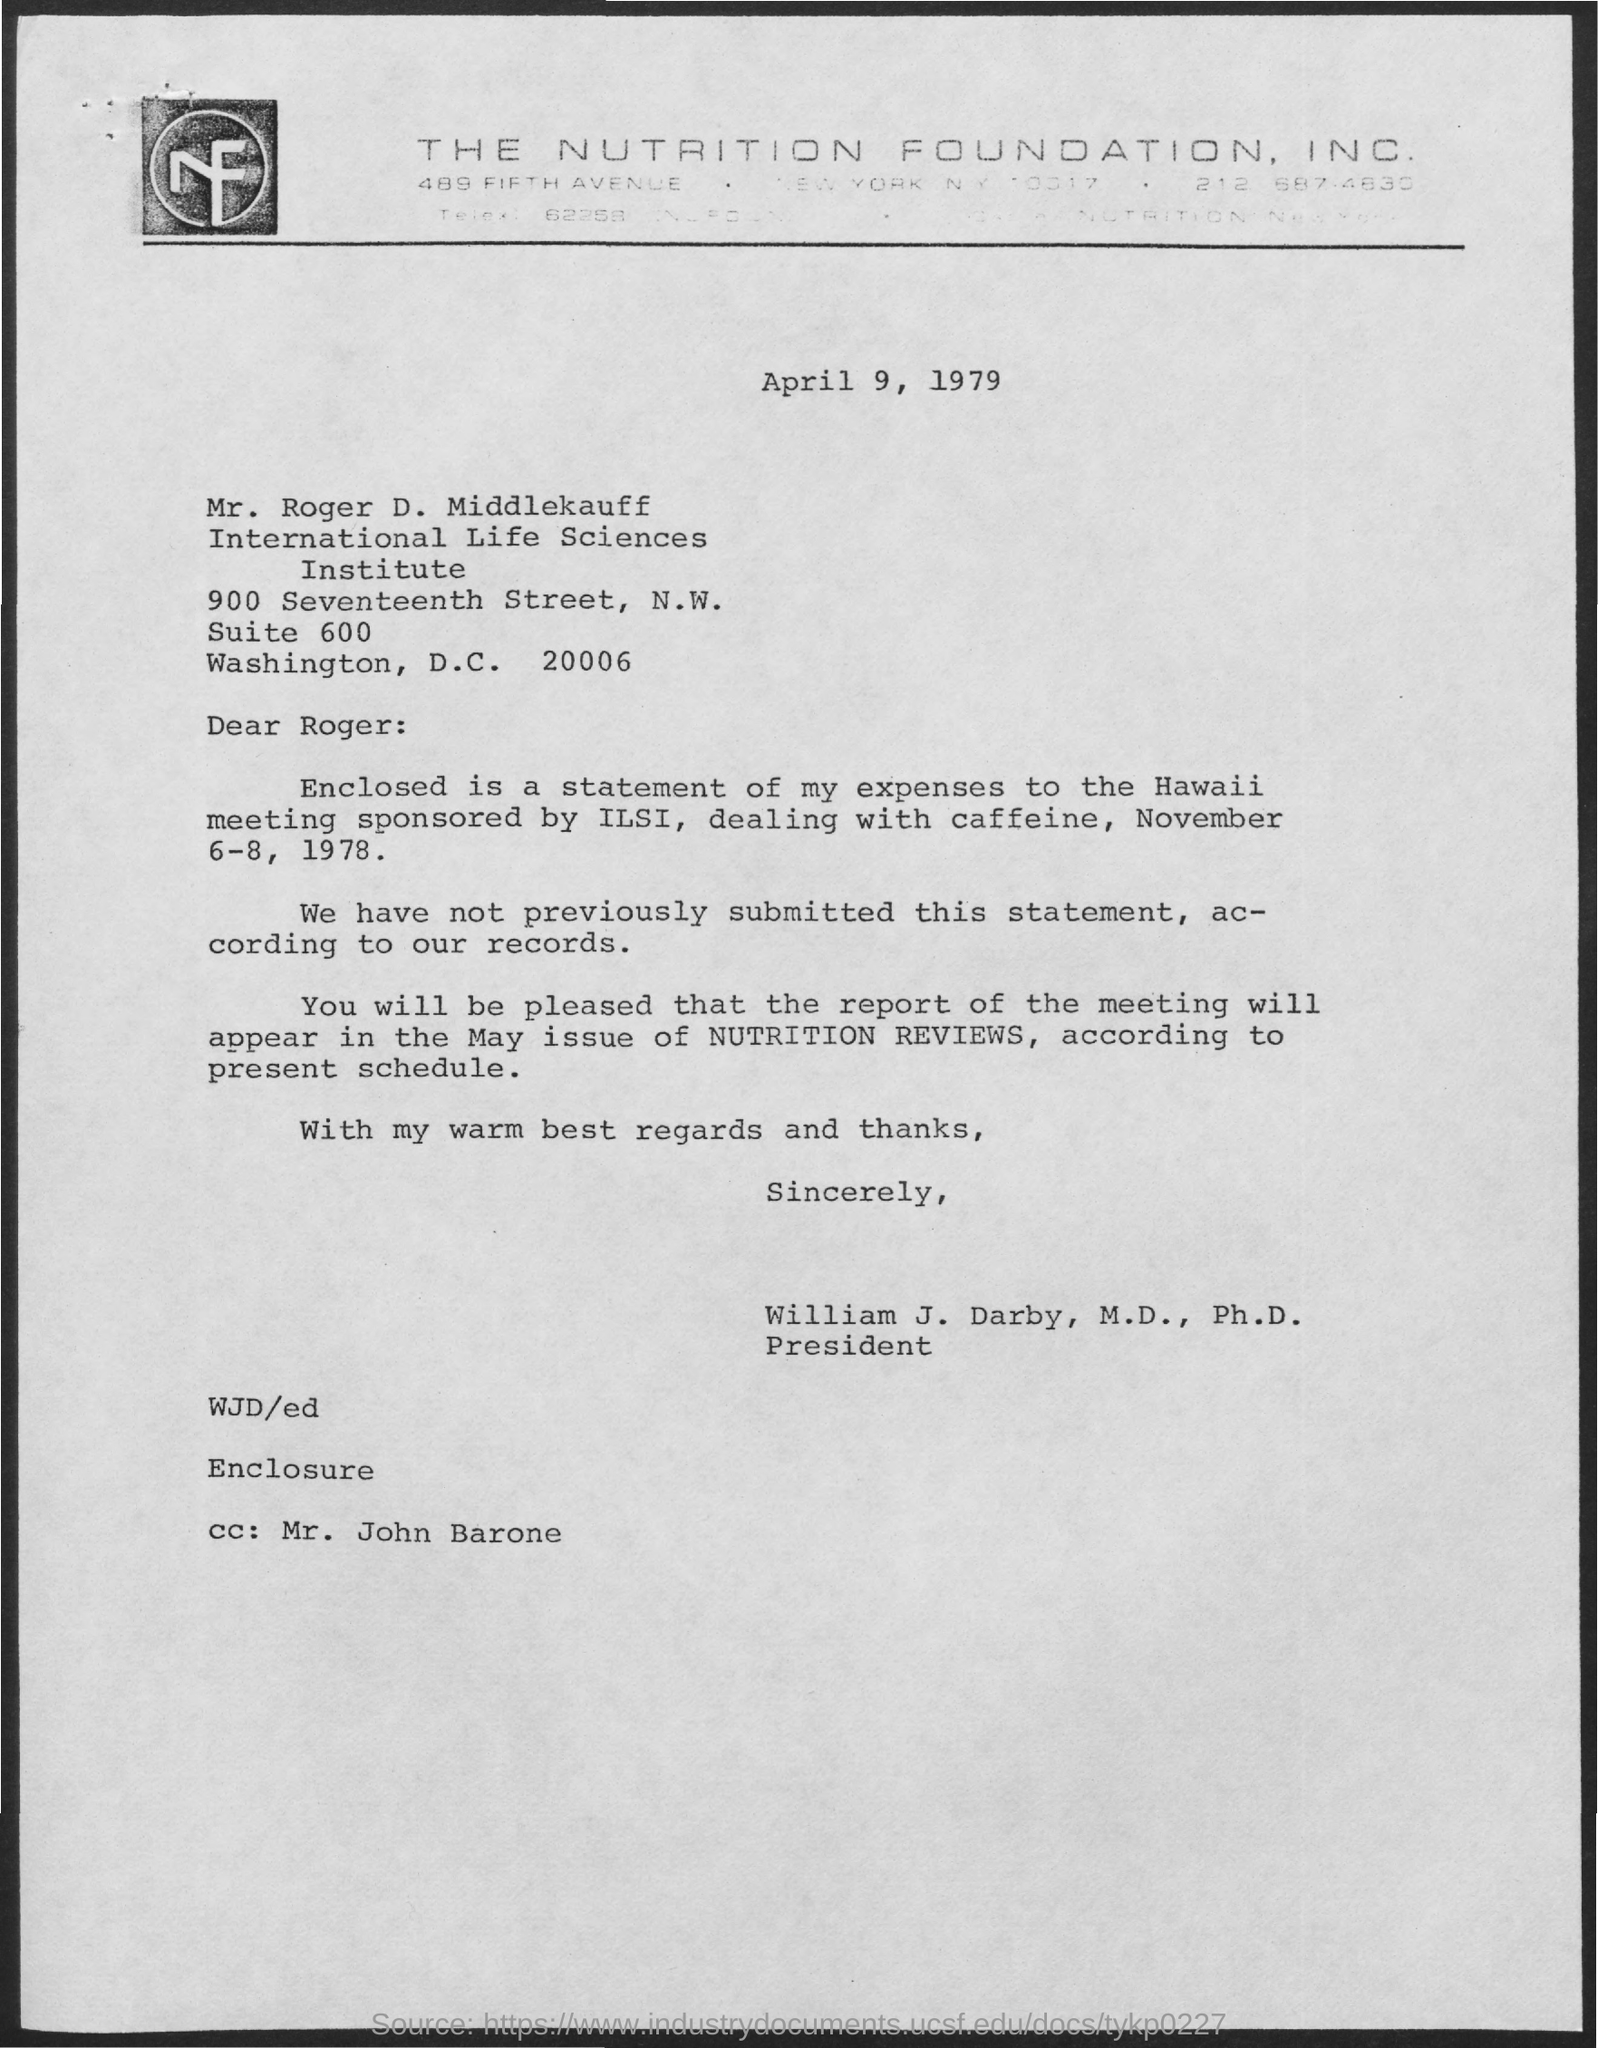Identify some key points in this picture. This letter is addressed to Mr. Roger D. Middlekauff. The date on the document is April 9, 1979. The report of the meeting will appear in the May issue of Nutrition Reviews. The letter is from William J. Darby, M.D., Ph.D. 